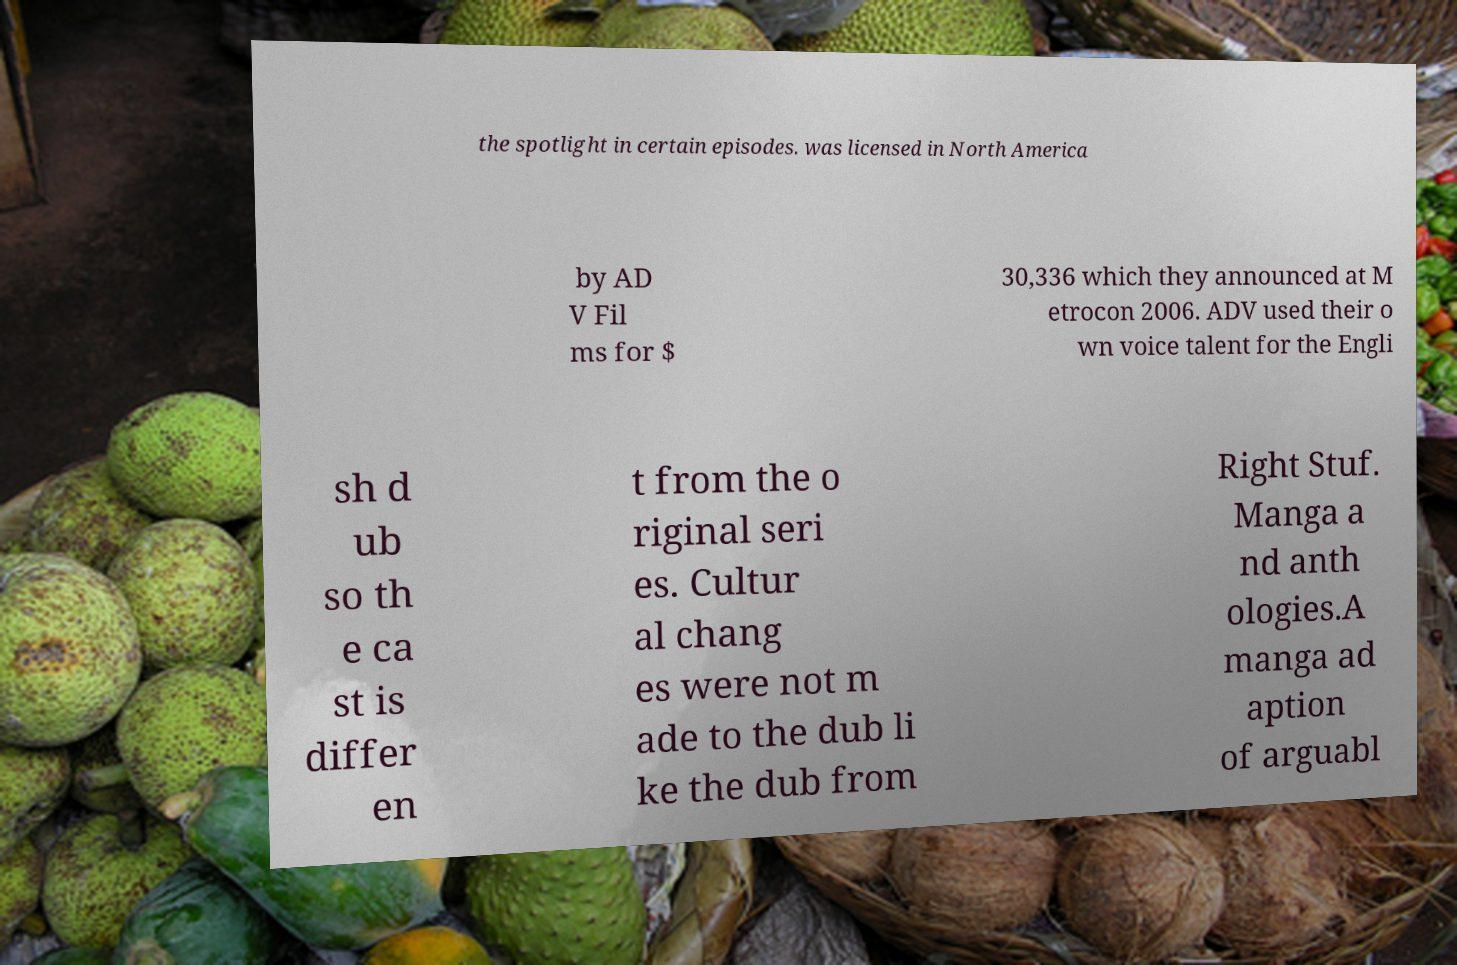Could you assist in decoding the text presented in this image and type it out clearly? the spotlight in certain episodes. was licensed in North America by AD V Fil ms for $ 30,336 which they announced at M etrocon 2006. ADV used their o wn voice talent for the Engli sh d ub so th e ca st is differ en t from the o riginal seri es. Cultur al chang es were not m ade to the dub li ke the dub from Right Stuf. Manga a nd anth ologies.A manga ad aption of arguabl 